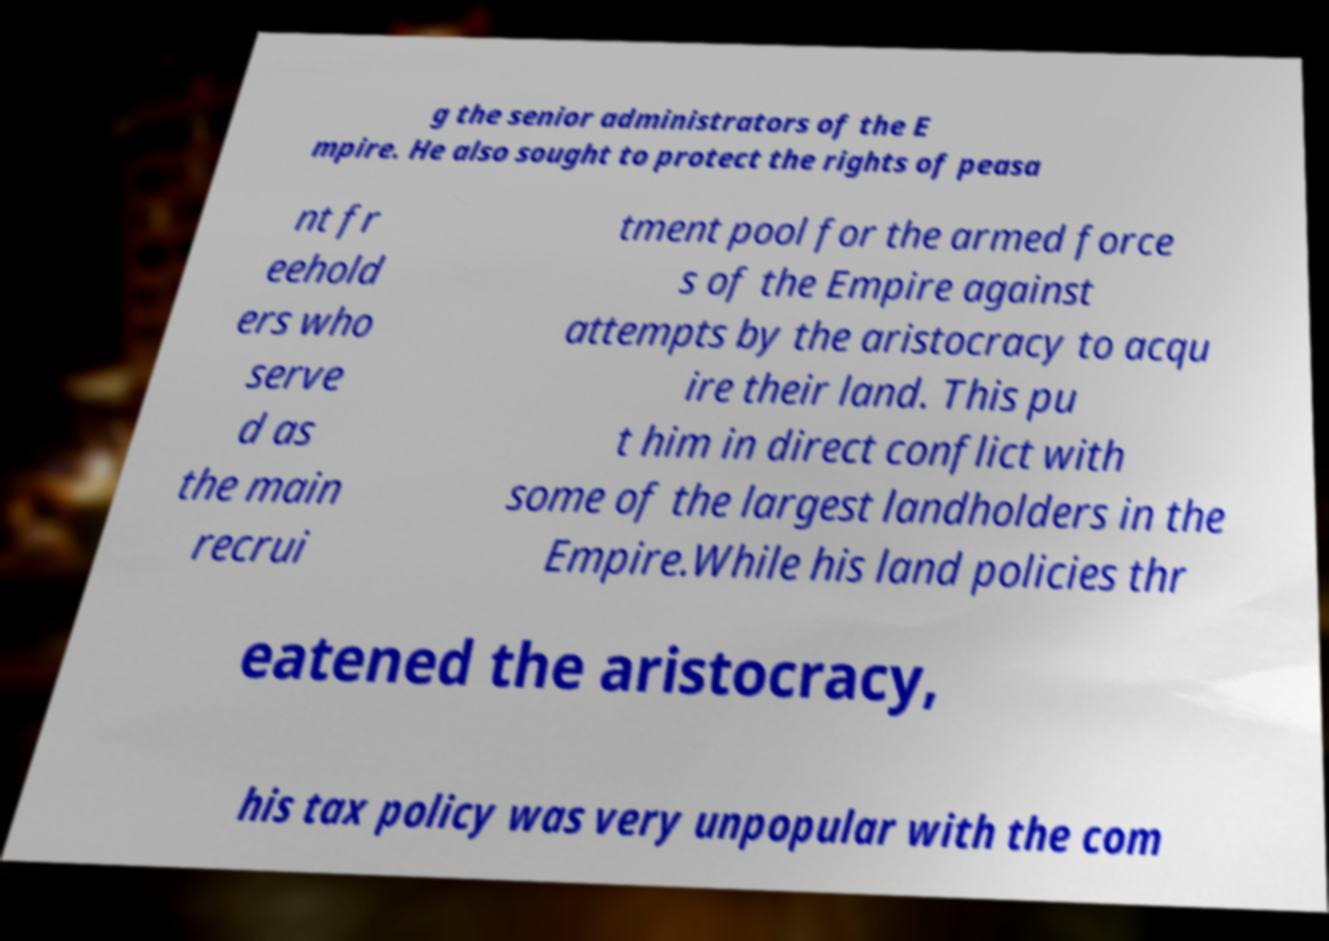I need the written content from this picture converted into text. Can you do that? g the senior administrators of the E mpire. He also sought to protect the rights of peasa nt fr eehold ers who serve d as the main recrui tment pool for the armed force s of the Empire against attempts by the aristocracy to acqu ire their land. This pu t him in direct conflict with some of the largest landholders in the Empire.While his land policies thr eatened the aristocracy, his tax policy was very unpopular with the com 